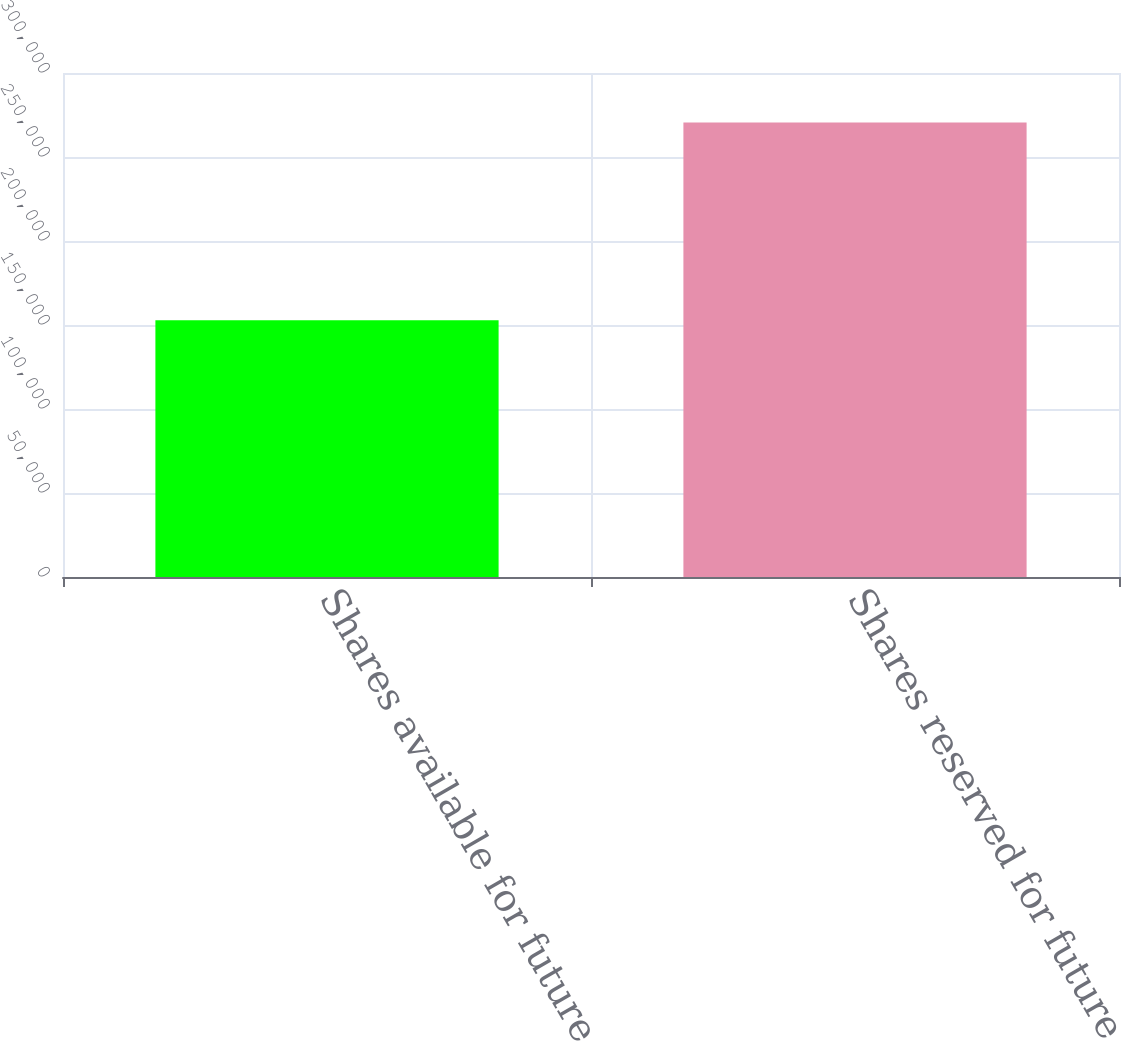<chart> <loc_0><loc_0><loc_500><loc_500><bar_chart><fcel>Shares available for future<fcel>Shares reserved for future<nl><fcel>152837<fcel>270498<nl></chart> 